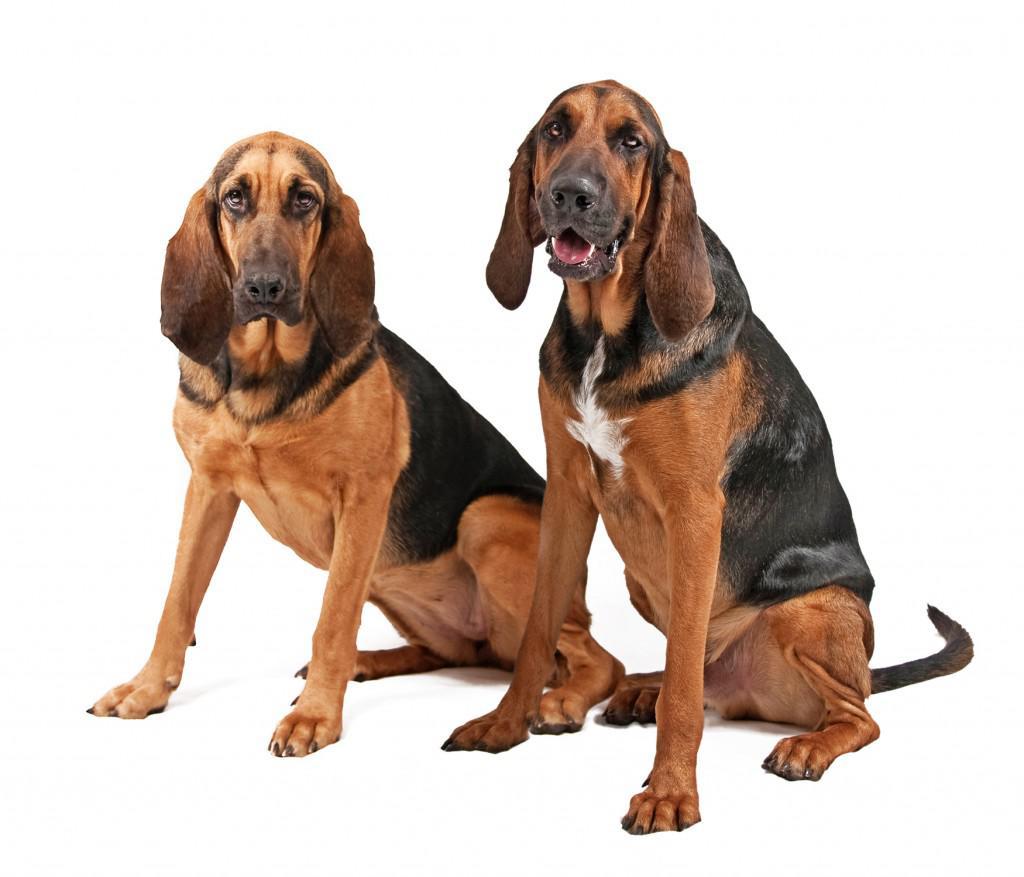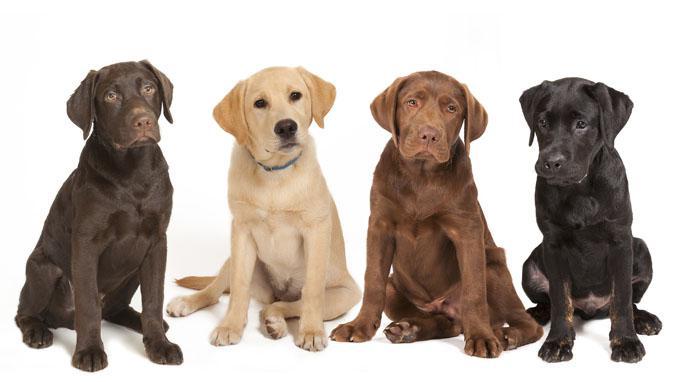The first image is the image on the left, the second image is the image on the right. Analyze the images presented: Is the assertion "In one image a group of dogs is four different colors, while in the other image, two dogs have the same coloring." valid? Answer yes or no. Yes. The first image is the image on the left, the second image is the image on the right. For the images displayed, is the sentence "The left image contains more dogs than the right image." factually correct? Answer yes or no. No. 